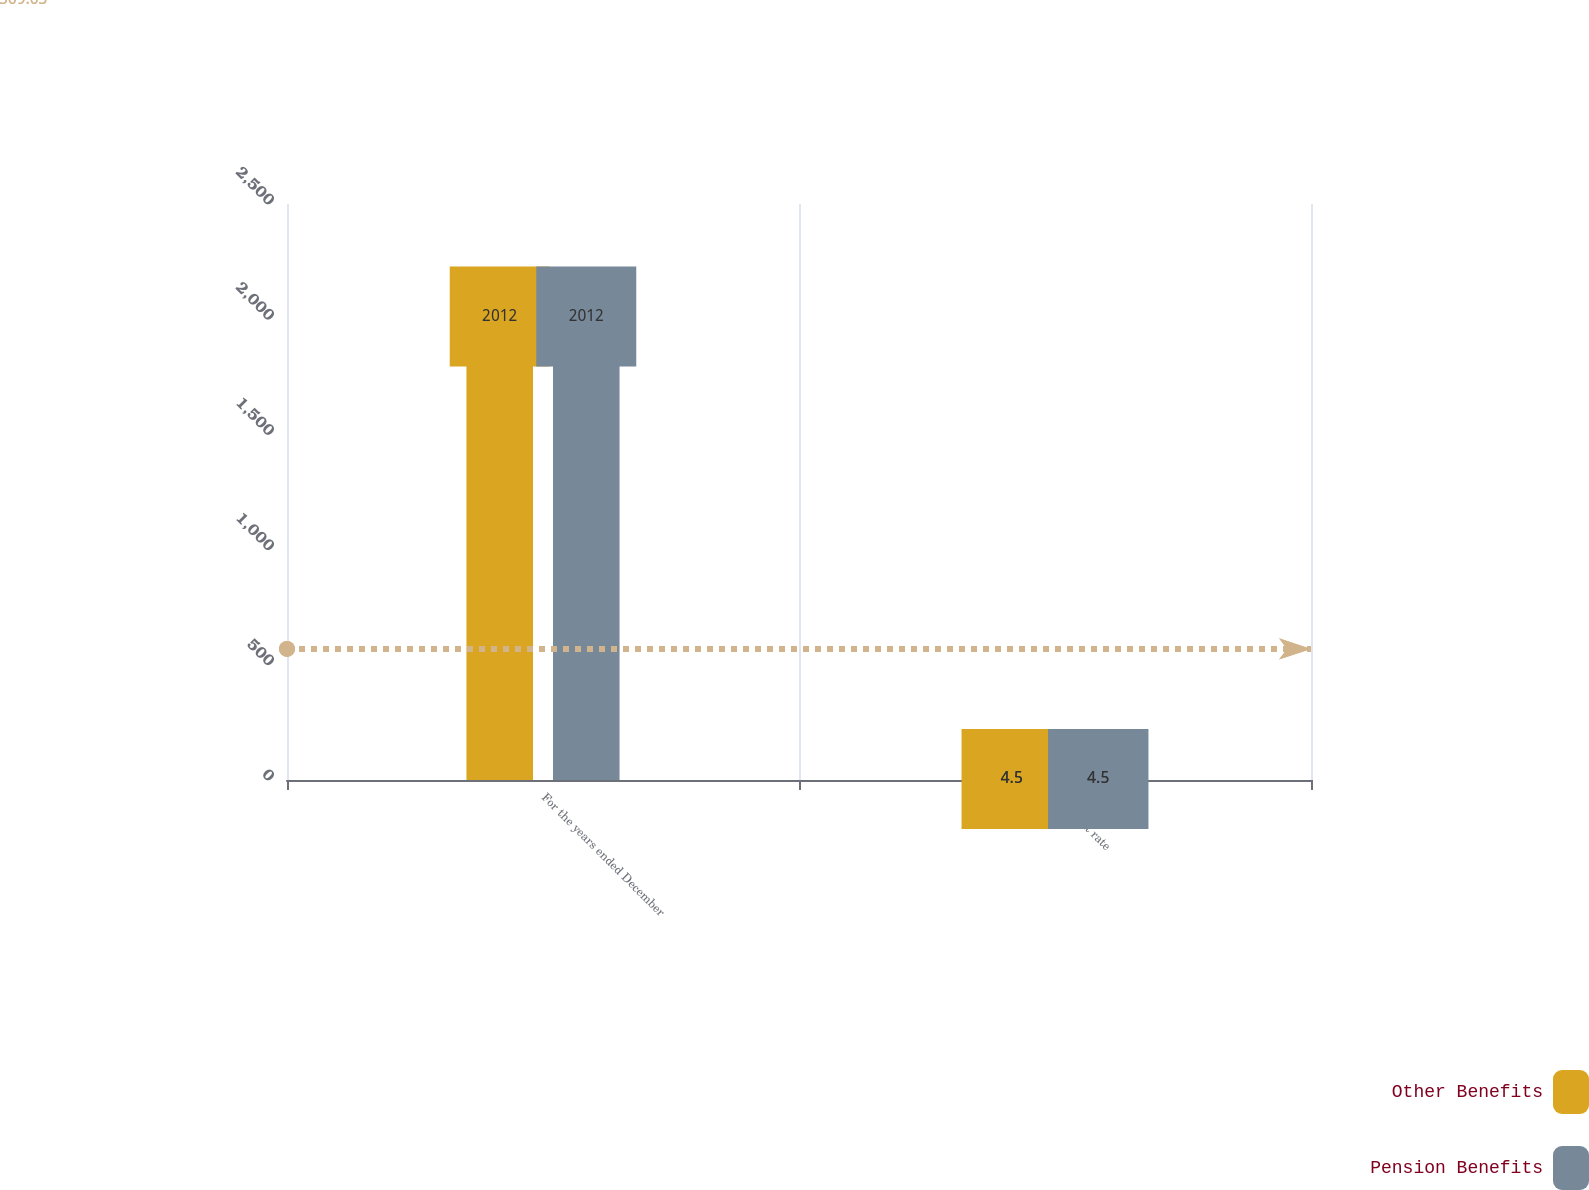Convert chart to OTSL. <chart><loc_0><loc_0><loc_500><loc_500><stacked_bar_chart><ecel><fcel>For the years ended December<fcel>Discount rate<nl><fcel>Other Benefits<fcel>2012<fcel>4.5<nl><fcel>Pension Benefits<fcel>2012<fcel>4.5<nl></chart> 